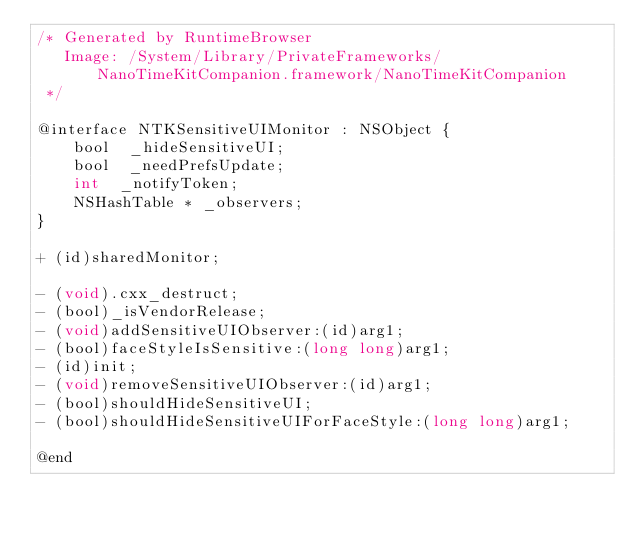Convert code to text. <code><loc_0><loc_0><loc_500><loc_500><_C_>/* Generated by RuntimeBrowser
   Image: /System/Library/PrivateFrameworks/NanoTimeKitCompanion.framework/NanoTimeKitCompanion
 */

@interface NTKSensitiveUIMonitor : NSObject {
    bool  _hideSensitiveUI;
    bool  _needPrefsUpdate;
    int  _notifyToken;
    NSHashTable * _observers;
}

+ (id)sharedMonitor;

- (void).cxx_destruct;
- (bool)_isVendorRelease;
- (void)addSensitiveUIObserver:(id)arg1;
- (bool)faceStyleIsSensitive:(long long)arg1;
- (id)init;
- (void)removeSensitiveUIObserver:(id)arg1;
- (bool)shouldHideSensitiveUI;
- (bool)shouldHideSensitiveUIForFaceStyle:(long long)arg1;

@end
</code> 